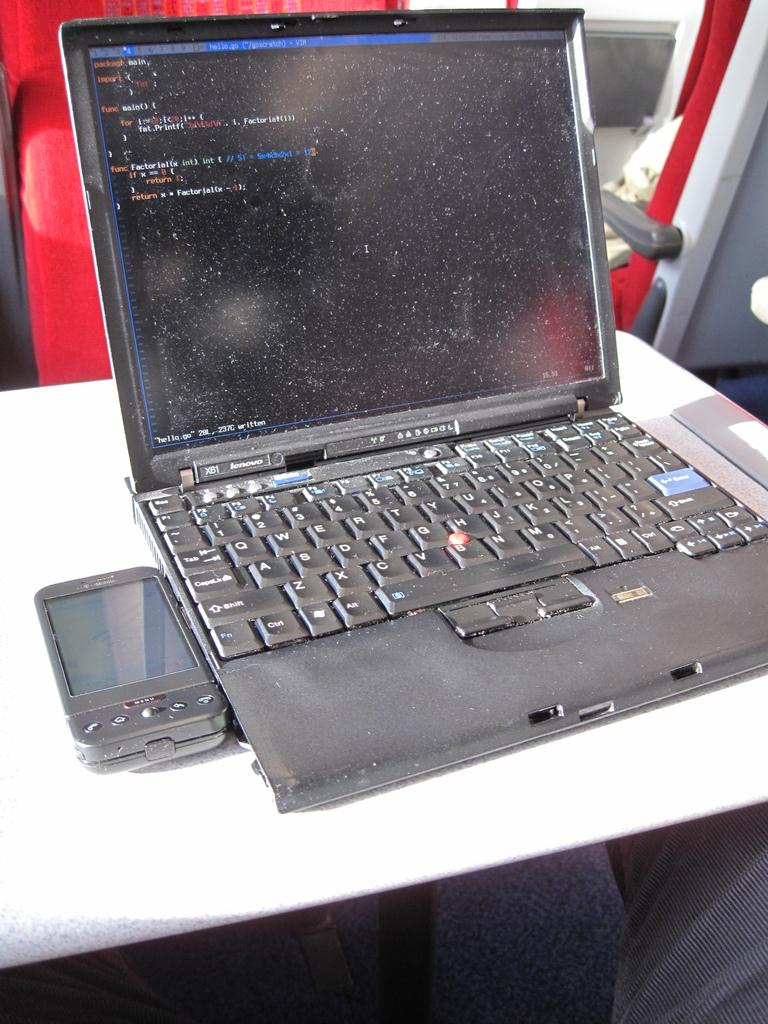<image>
Describe the image concisely. X61 Lenovo computer and a black T-Mobile phone. 